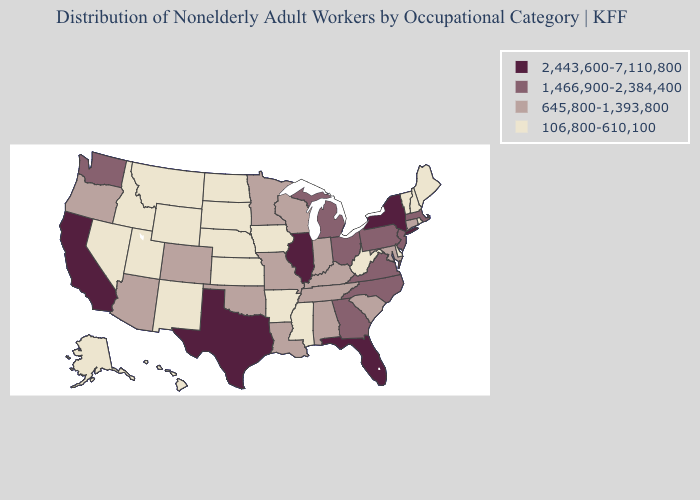Name the states that have a value in the range 2,443,600-7,110,800?
Write a very short answer. California, Florida, Illinois, New York, Texas. What is the value of Texas?
Quick response, please. 2,443,600-7,110,800. Does Washington have a lower value than Kentucky?
Short answer required. No. Among the states that border Minnesota , does Iowa have the lowest value?
Concise answer only. Yes. Name the states that have a value in the range 645,800-1,393,800?
Concise answer only. Alabama, Arizona, Colorado, Connecticut, Indiana, Kentucky, Louisiana, Maryland, Minnesota, Missouri, Oklahoma, Oregon, South Carolina, Tennessee, Wisconsin. What is the highest value in the West ?
Short answer required. 2,443,600-7,110,800. Does the first symbol in the legend represent the smallest category?
Concise answer only. No. What is the value of Hawaii?
Concise answer only. 106,800-610,100. Does the map have missing data?
Give a very brief answer. No. Name the states that have a value in the range 2,443,600-7,110,800?
Concise answer only. California, Florida, Illinois, New York, Texas. Does the map have missing data?
Write a very short answer. No. Which states hav the highest value in the South?
Write a very short answer. Florida, Texas. Does the first symbol in the legend represent the smallest category?
Be succinct. No. Name the states that have a value in the range 645,800-1,393,800?
Be succinct. Alabama, Arizona, Colorado, Connecticut, Indiana, Kentucky, Louisiana, Maryland, Minnesota, Missouri, Oklahoma, Oregon, South Carolina, Tennessee, Wisconsin. Name the states that have a value in the range 1,466,900-2,384,400?
Be succinct. Georgia, Massachusetts, Michigan, New Jersey, North Carolina, Ohio, Pennsylvania, Virginia, Washington. 